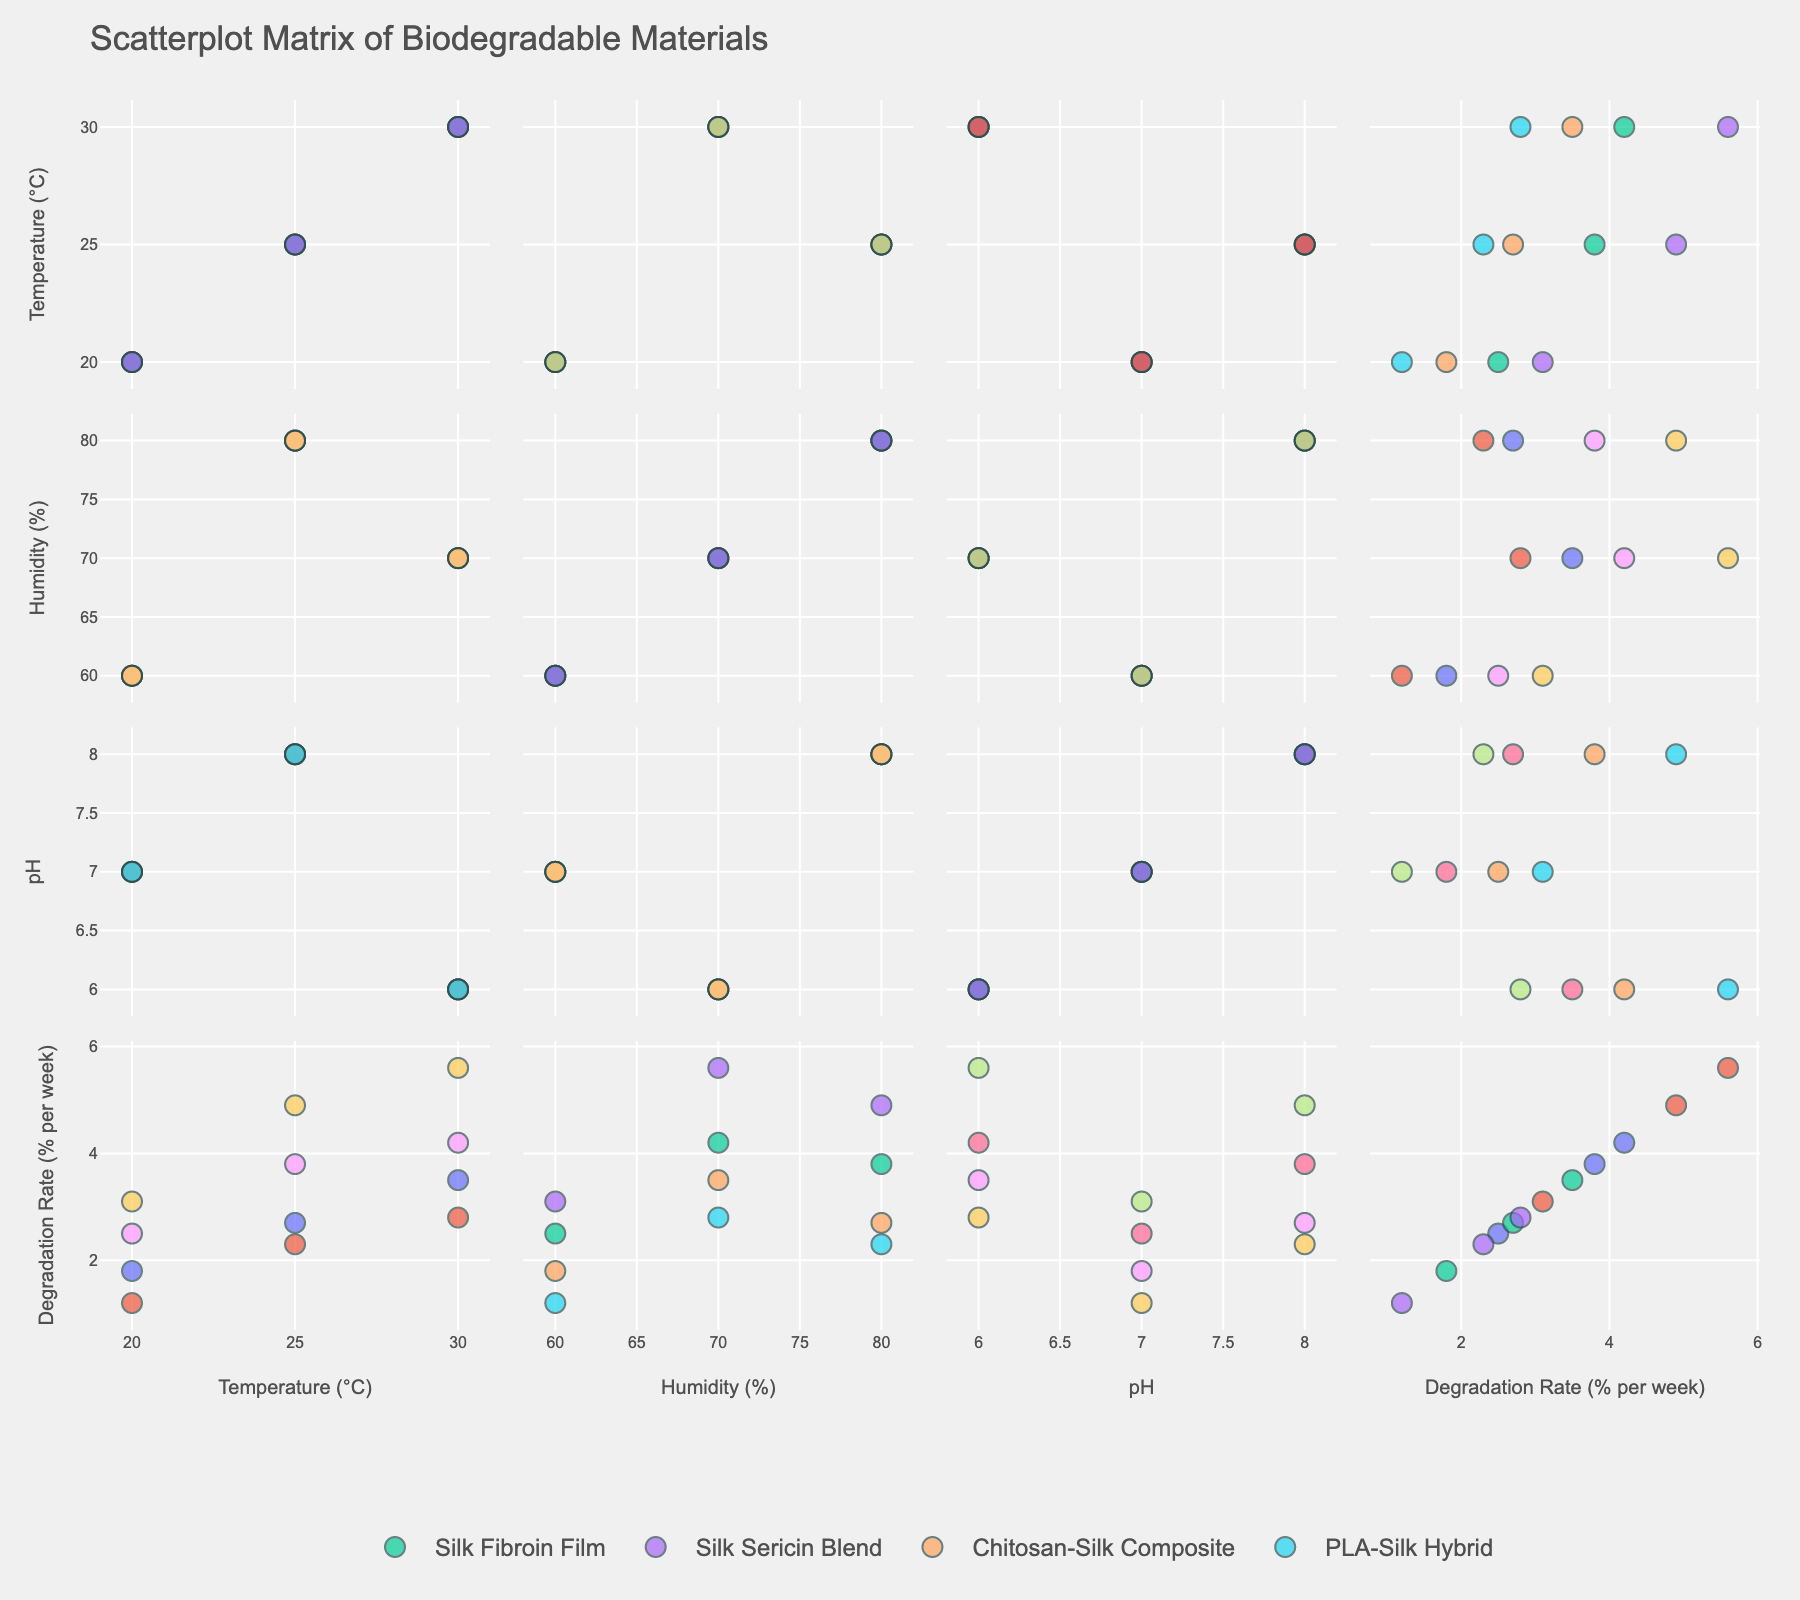What is the title of the scatterplot matrix? The title is usually found at the top of the figure and typically summarizes the content or purpose of the plot.
Answer: "Scatterplot Matrix of Biodegradable Materials" Which material generally shows the highest degradation rate under varying conditions? By inspecting the scatter plots, look for the material with the highest degradation rate values across different conditions.
Answer: Silk Sericin Blend How does Temperature (°C) correlate with Degradation Rate (% per week) across different materials? Examine the scatter plots for each material correlating Temperature (°C) with Degradation Rate (% per week) to identify any apparent trends or patterns.
Answer: Positive correlation Which variable appears to have the least variation in its scatter plots across all the materials? Observe the scatter plots for which the data points are most closely clustered together; this indicates less variation.
Answer: pH When comparing Silk Fibroin Film and PLA-Silk Hybrid, which material generally has a lower degradation rate at 30°C? Compare the data points for these two materials at the temperature of 30°C and see which degradation rates are lower.
Answer: PLA-Silk Hybrid What is the degradation rate of the Chitosan-Silk Composite material at a humidity of 80% and a pH of 8? Look up the data point where Humidity is 80% and pH is 8 for Chitosan-Silk Composite to find the corresponding degradation rate.
Answer: 2.7 Which material shows the most significant change in degradation rate with varying temperature? Examine the scatter plots for each material and focus on how steeply the degradation rates change with temperature.
Answer: Silk Sericin Blend Do any materials exhibit a degradation rate lower than 2% per week in all conditions? If so, which one(s)? Check all the scatter plots to see if any material consistently has degradation rates below 2% per week.
Answer: PLA-Silk Hybrid Which environmental condition (Temperature, Humidity, or pH) has the strongest influence on degradation rates for the materials? Analyze the overall scatter plots to determine which condition shows the most significant trends or patterns affecting the degradation rates.
Answer: Temperature On average, which material shows the highest degradation rate? Calculate the average degradation rate for each material by summing their degradation rates and dividing by the number of data points for each material, then compare.
Answer: Silk Sericin Blend 